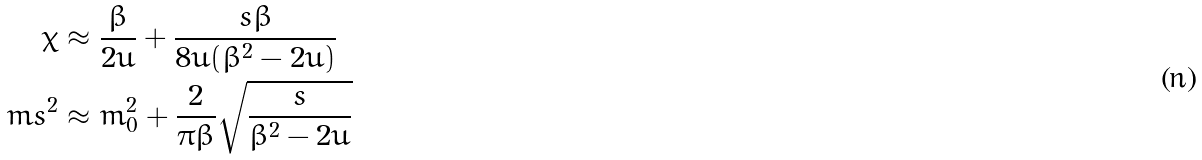Convert formula to latex. <formula><loc_0><loc_0><loc_500><loc_500>\chi & \approx \frac { \beta } { 2 u } + \frac { s \beta } { 8 u ( \beta ^ { 2 } - 2 u ) } \\ \ m s ^ { 2 } & \approx m _ { 0 } ^ { 2 } + \frac { 2 } { \pi \beta } \sqrt { \frac { s } { \beta ^ { 2 } - 2 u } }</formula> 